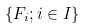Convert formula to latex. <formula><loc_0><loc_0><loc_500><loc_500>\{ F _ { i } ; i \in I \}</formula> 